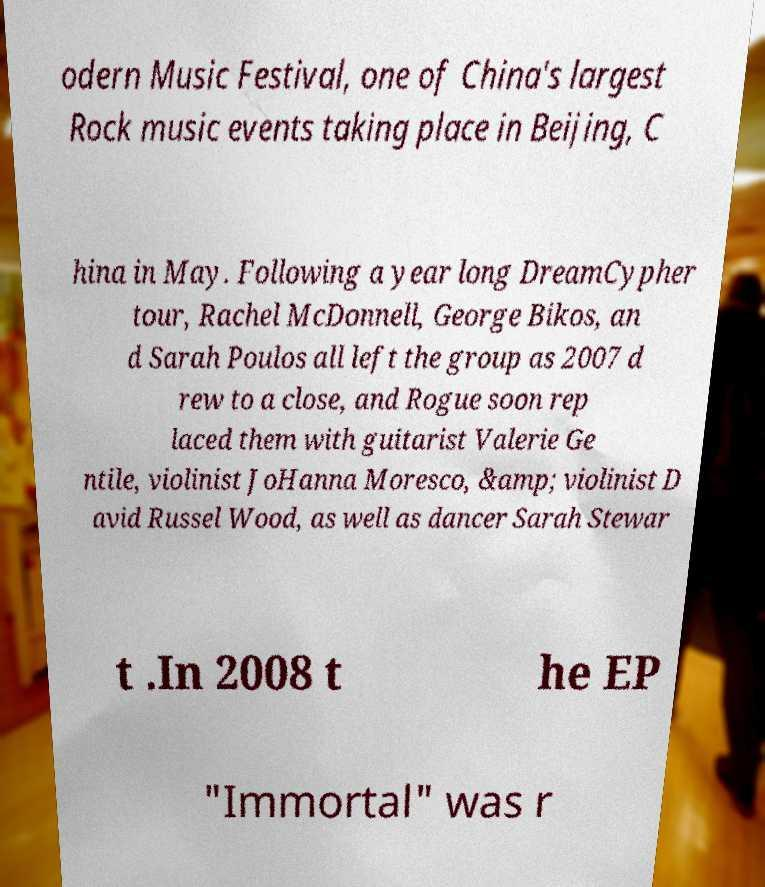Can you accurately transcribe the text from the provided image for me? odern Music Festival, one of China's largest Rock music events taking place in Beijing, C hina in May. Following a year long DreamCypher tour, Rachel McDonnell, George Bikos, an d Sarah Poulos all left the group as 2007 d rew to a close, and Rogue soon rep laced them with guitarist Valerie Ge ntile, violinist JoHanna Moresco, &amp; violinist D avid Russel Wood, as well as dancer Sarah Stewar t .In 2008 t he EP "Immortal" was r 